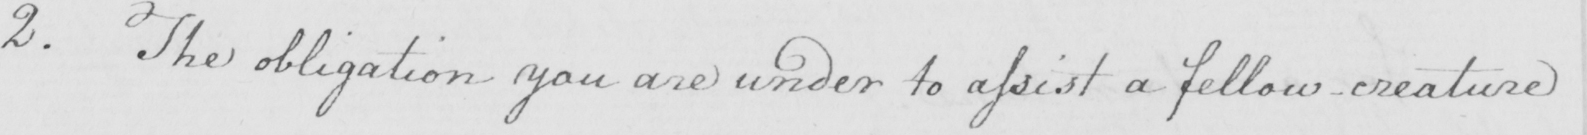Transcribe the text shown in this historical manuscript line. 2 . The obligation you are under to assist a fellow creature 